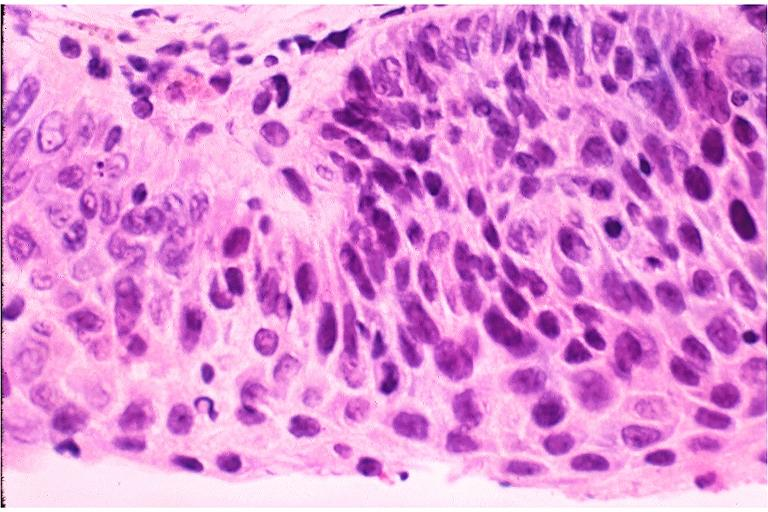s oral present?
Answer the question using a single word or phrase. Yes 